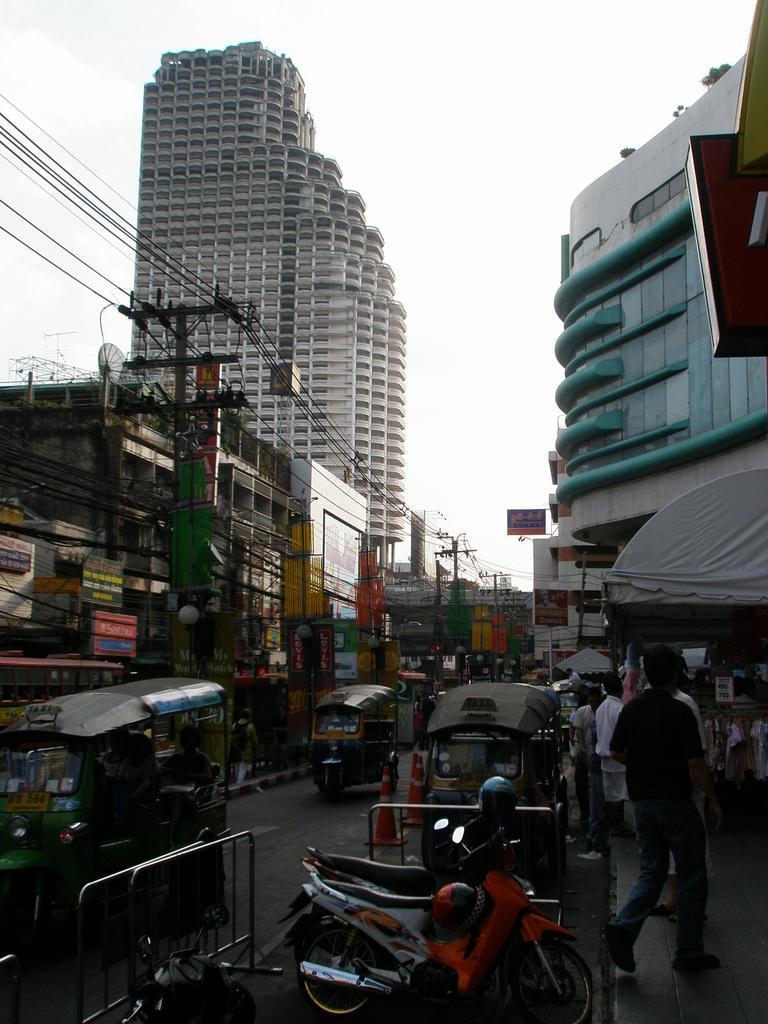Please provide a concise description of this image. In this image there is the sky truncated towards the top of the image, there are buildings, there are buildings truncated towards the left of the image, there are buildings truncated towards the right of the image, there are object truncated towards the right of the image, there are poles, there are wires truncated towards the left of the image, there is the road truncated towards the bottom of the image, there are vehicles on the road, there are persons on the road, there are objects on the road, there are boards, there are text on the boards. 